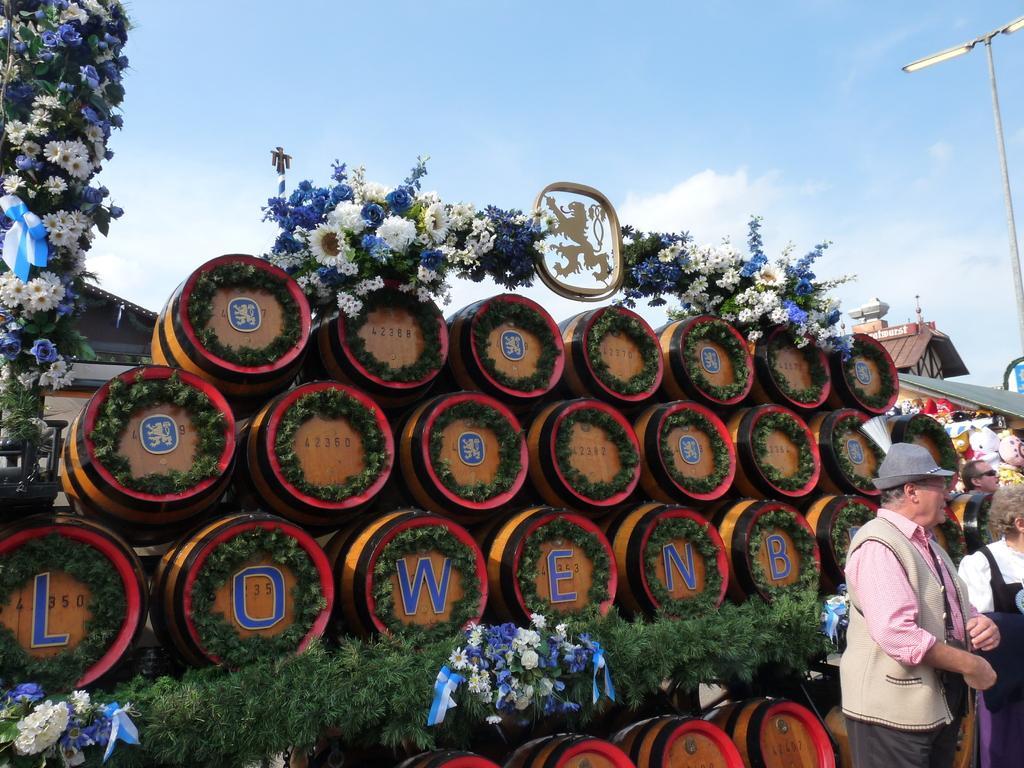In one or two sentences, can you explain what this image depicts? In this image in the front there are plants and there are objects which are brown and green in colour and there are flowers. On the right side there are persons, there is a pole and there is a house. In the background there is a house and the sky is cloudy. 